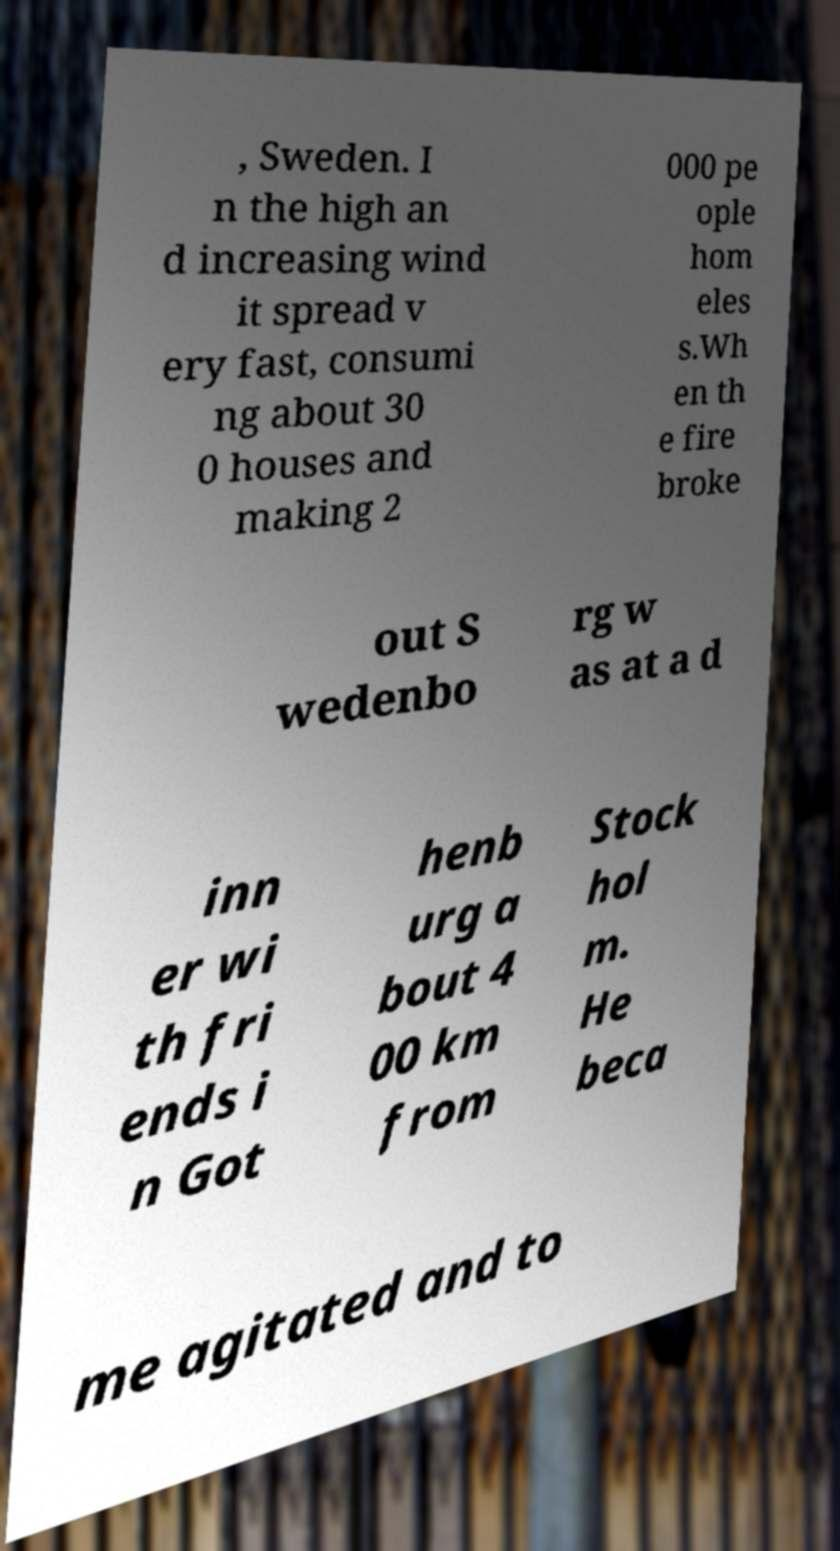Can you read and provide the text displayed in the image?This photo seems to have some interesting text. Can you extract and type it out for me? , Sweden. I n the high an d increasing wind it spread v ery fast, consumi ng about 30 0 houses and making 2 000 pe ople hom eles s.Wh en th e fire broke out S wedenbo rg w as at a d inn er wi th fri ends i n Got henb urg a bout 4 00 km from Stock hol m. He beca me agitated and to 